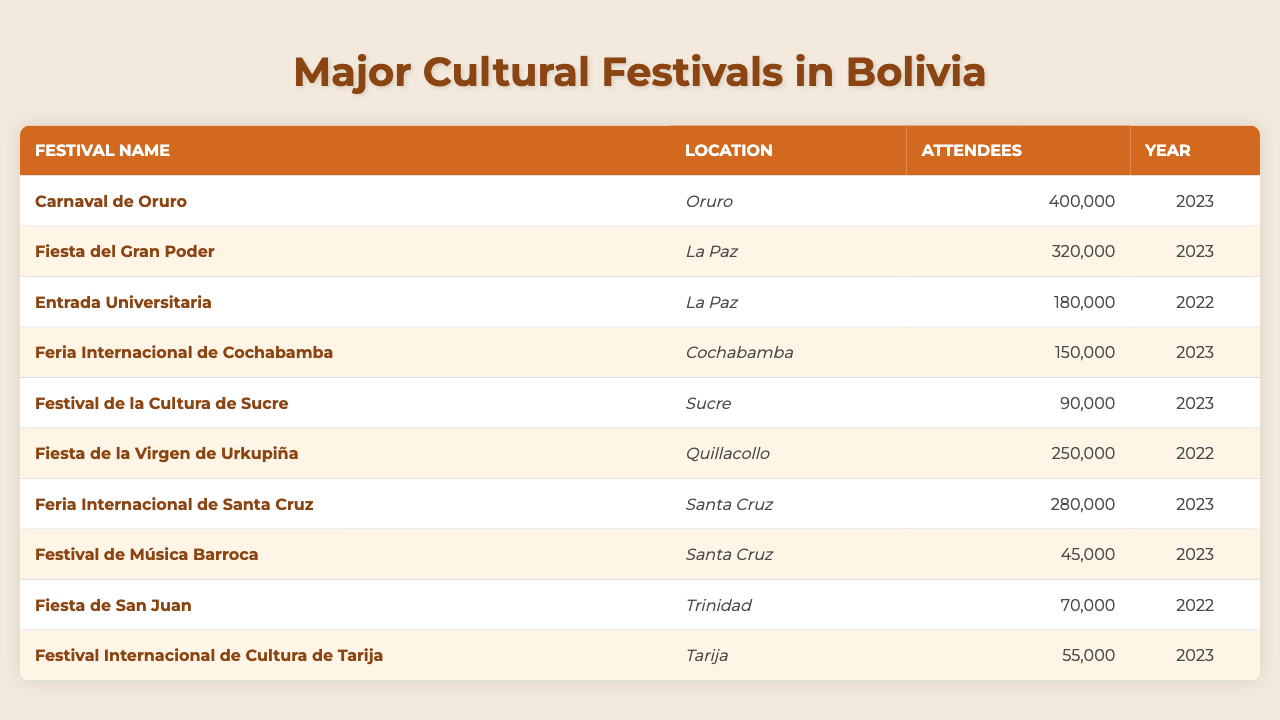What is the location of the Carnaval de Oruro? The table shows that the Carnaval de Oruro is located in Oruro.
Answer: Oruro How many attendees did the Fiesta del Gran Poder have in 2023? According to the table, the Fiesta del Gran Poder had 320,000 attendees in 2023.
Answer: 320000 Which festival had the least number of attendees in 2023? The table indicates that the Festival de Música Barroca had 45,000 attendees, which is the least for the year 2023.
Answer: Festival de Música Barroca What is the difference in attendance between the Feria Internacional de Cochabamba and the Festival de la Cultura de Sucre in 2023? The Feria Internacional de Cochabamba had 150,000 attendees, while the Festival de la Cultura de Sucre had 90,000 attendees. The difference is 150,000 - 90,000 = 60,000.
Answer: 60000 Is the Fiesta de San Juan listed in the table for the year 2023? The table does not include the Fiesta de San Juan for 2023; it is listed for 2022.
Answer: No What is the total number of attendees for all festivals listed in 2023? Adding the attendees for the festivals in 2023: 400,000 (Carnaval de Oruro) + 320,000 (Fiesta del Gran Poder) + 150,000 (Feria Internacional de Cochabamba) + 280,000 (Feria Internacional de Santa Cruz) + 90,000 (Festival de la Cultura de Sucre) + 45,000 (Festival de Música Barroca) = 1,285,000.
Answer: 1285000 Which festival had more attendees: Fiesta de la Virgen de Urkupiña or Entrada Universitaria? The Fiesta de la Virgen de Urkupiña had 250,000 attendees in 2022, while Entrada Universitaria had 180,000 attendees in 2022. Since 250,000 > 180,000, the Fiesta de la Virgen de Urkupiña had more.
Answer: Fiesta de la Virgen de Urkupiña How many festivals listed in the table had over 200,000 attendees? Counting the festivals over 200,000 attendees: Carnaval de Oruro (400,000), Fiesta del Gran Poder (320,000), Fiesta de la Virgen de Urkupiña (250,000), and Feria Internacional de Santa Cruz (280,000) gives a total of four festivals.
Answer: 4 